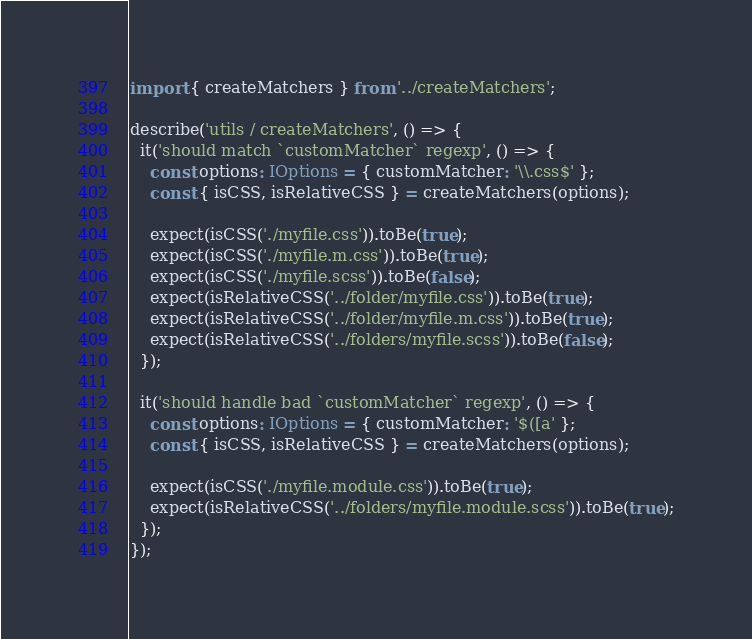Convert code to text. <code><loc_0><loc_0><loc_500><loc_500><_TypeScript_>import { createMatchers } from '../createMatchers';

describe('utils / createMatchers', () => {
  it('should match `customMatcher` regexp', () => {
    const options: IOptions = { customMatcher: '\\.css$' };
    const { isCSS, isRelativeCSS } = createMatchers(options);

    expect(isCSS('./myfile.css')).toBe(true);
    expect(isCSS('./myfile.m.css')).toBe(true);
    expect(isCSS('./myfile.scss')).toBe(false);
    expect(isRelativeCSS('../folder/myfile.css')).toBe(true);
    expect(isRelativeCSS('../folder/myfile.m.css')).toBe(true);
    expect(isRelativeCSS('../folders/myfile.scss')).toBe(false);
  });

  it('should handle bad `customMatcher` regexp', () => {
    const options: IOptions = { customMatcher: '$([a' };
    const { isCSS, isRelativeCSS } = createMatchers(options);

    expect(isCSS('./myfile.module.css')).toBe(true);
    expect(isRelativeCSS('../folders/myfile.module.scss')).toBe(true);
  });
});
</code> 